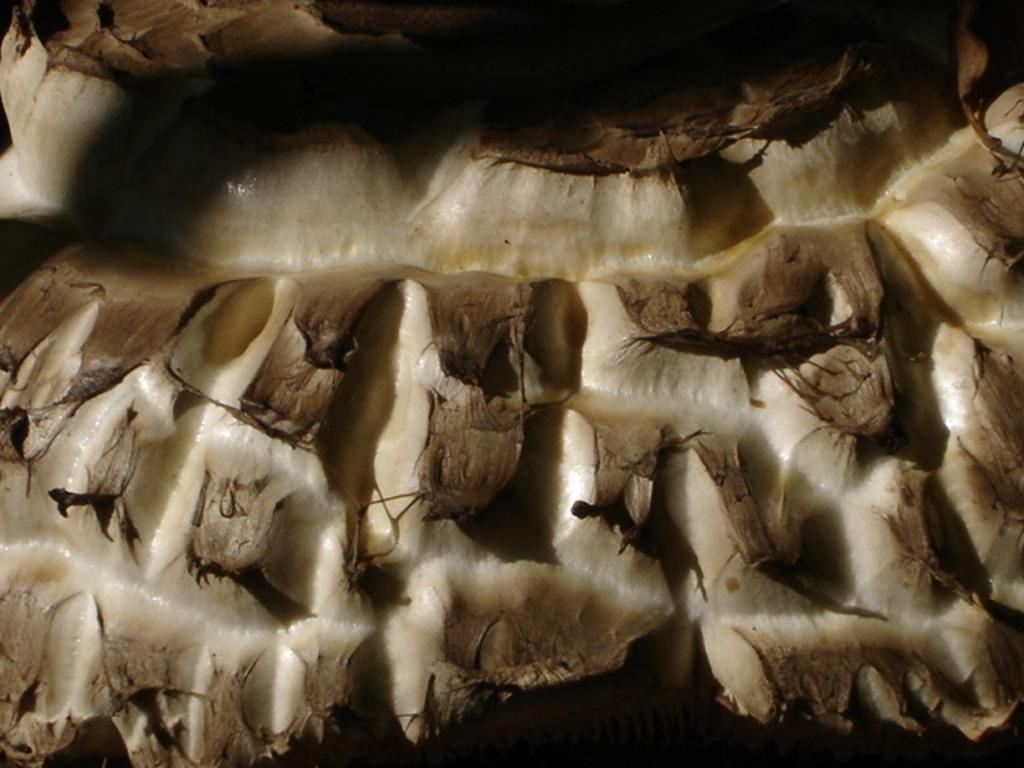What type of environment is shown in the image? The image depicts a wooded area. Can you describe the vegetation present in the image? The wooded area consists of trees and other plant life. Are there any structures or man-made objects visible in the image? The provided facts do not mention any structures or man-made objects in the image. What type of meal is being prepared in the wooded area? There is no indication of a meal being prepared in the image, as it depicts a wooded area without any human presence or activity. 